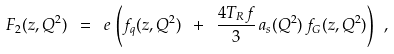<formula> <loc_0><loc_0><loc_500><loc_500>F _ { 2 } ( z , Q ^ { 2 } ) \ = \ e \, \left ( f _ { q } ( z , Q ^ { 2 } ) \ + \ \frac { 4 T _ { R } f } { 3 } \, a _ { s } ( Q ^ { 2 } ) \, f _ { G } ( z , Q ^ { 2 } ) \right ) \ ,</formula> 